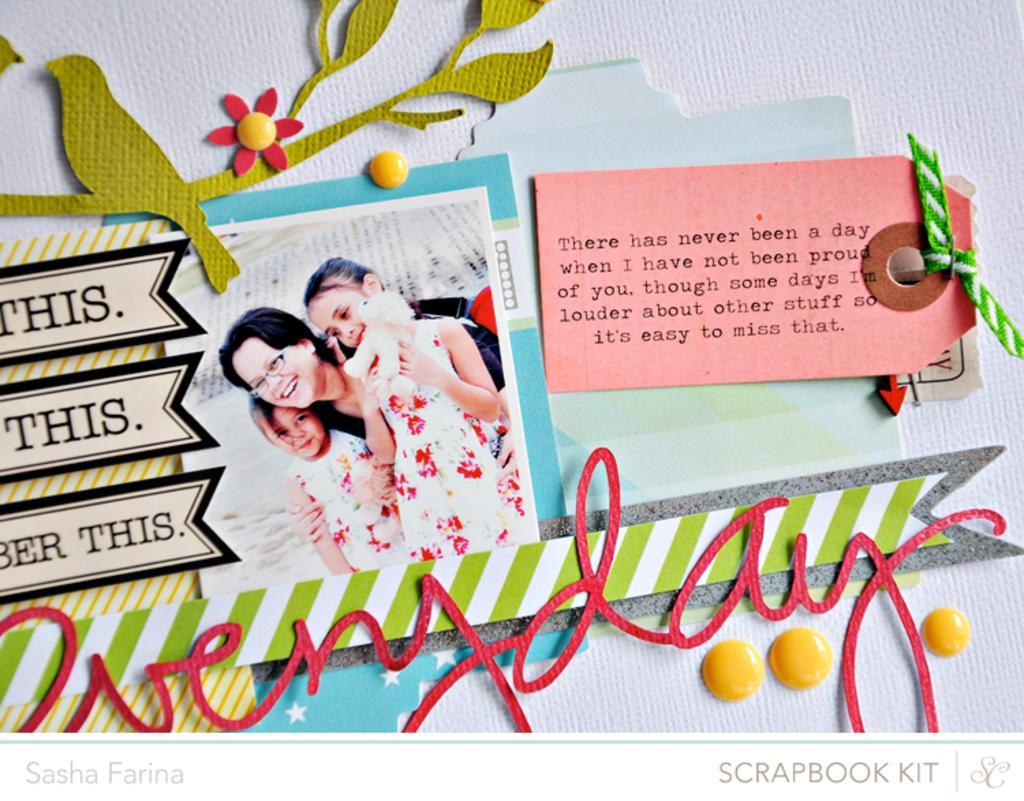Could you give a brief overview of what you see in this image? In this image I can see the white colored surface and on it I can see few papers and a picture of few persons standing. 